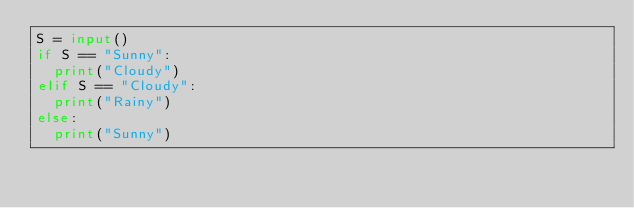<code> <loc_0><loc_0><loc_500><loc_500><_Python_>S = input()
if S == "Sunny":
  print("Cloudy")
elif S == "Cloudy":
  print("Rainy")
else:
  print("Sunny")</code> 